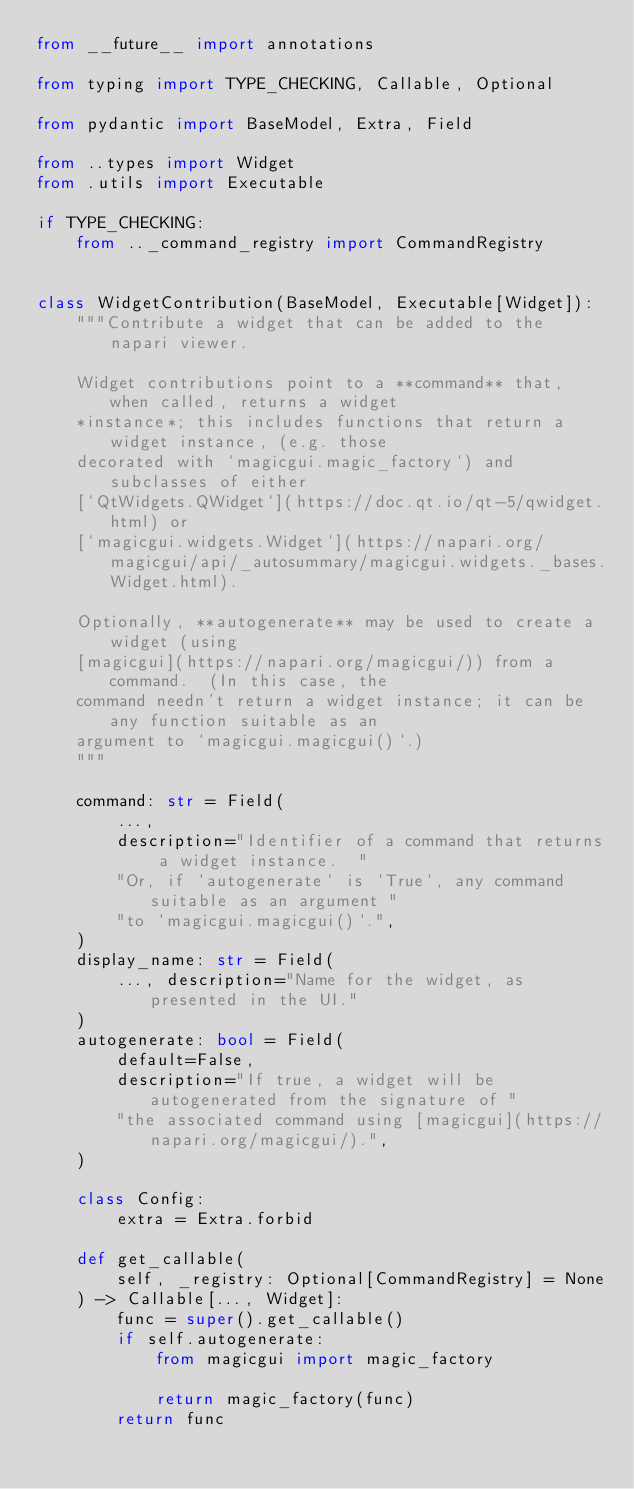<code> <loc_0><loc_0><loc_500><loc_500><_Python_>from __future__ import annotations

from typing import TYPE_CHECKING, Callable, Optional

from pydantic import BaseModel, Extra, Field

from ..types import Widget
from .utils import Executable

if TYPE_CHECKING:
    from .._command_registry import CommandRegistry


class WidgetContribution(BaseModel, Executable[Widget]):
    """Contribute a widget that can be added to the napari viewer.

    Widget contributions point to a **command** that, when called, returns a widget
    *instance*; this includes functions that return a widget instance, (e.g. those
    decorated with `magicgui.magic_factory`) and subclasses of either
    [`QtWidgets.QWidget`](https://doc.qt.io/qt-5/qwidget.html) or
    [`magicgui.widgets.Widget`](https://napari.org/magicgui/api/_autosummary/magicgui.widgets._bases.Widget.html).

    Optionally, **autogenerate** may be used to create a widget (using
    [magicgui](https://napari.org/magicgui/)) from a command.  (In this case, the
    command needn't return a widget instance; it can be any function suitable as an
    argument to `magicgui.magicgui()`.)
    """

    command: str = Field(
        ...,
        description="Identifier of a command that returns a widget instance.  "
        "Or, if `autogenerate` is `True`, any command suitable as an argument "
        "to `magicgui.magicgui()`.",
    )
    display_name: str = Field(
        ..., description="Name for the widget, as presented in the UI."
    )
    autogenerate: bool = Field(
        default=False,
        description="If true, a widget will be autogenerated from the signature of "
        "the associated command using [magicgui](https://napari.org/magicgui/).",
    )

    class Config:
        extra = Extra.forbid

    def get_callable(
        self, _registry: Optional[CommandRegistry] = None
    ) -> Callable[..., Widget]:
        func = super().get_callable()
        if self.autogenerate:
            from magicgui import magic_factory

            return magic_factory(func)
        return func
</code> 